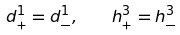<formula> <loc_0><loc_0><loc_500><loc_500>d ^ { 1 } _ { + } = d ^ { 1 } _ { - } , \quad h ^ { 3 } _ { + } = h ^ { 3 } _ { - }</formula> 